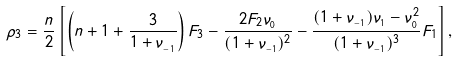Convert formula to latex. <formula><loc_0><loc_0><loc_500><loc_500>\rho _ { 3 } = \frac { n } { 2 } \left [ \left ( n + 1 + \frac { 3 } { 1 + \nu _ { _ { - 1 } } } \right ) F _ { 3 } - \frac { 2 F _ { 2 } \nu _ { _ { 0 } } } { ( 1 + \nu _ { _ { - 1 } } ) ^ { 2 } } - \frac { ( 1 + \nu _ { _ { - 1 } } ) \nu _ { _ { 1 } } - \nu _ { _ { 0 } } ^ { 2 } } { ( 1 + \nu _ { _ { - 1 } } ) ^ { 3 } } F _ { 1 } \right ] ,</formula> 